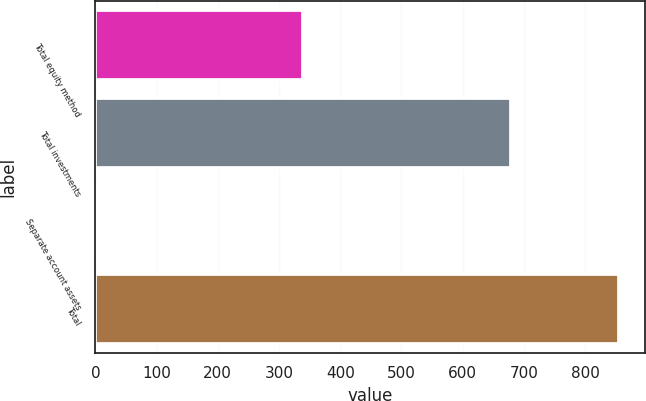<chart> <loc_0><loc_0><loc_500><loc_500><bar_chart><fcel>Total equity method<fcel>Total investments<fcel>Separate account assets<fcel>Total<nl><fcel>339<fcel>679<fcel>2<fcel>855<nl></chart> 